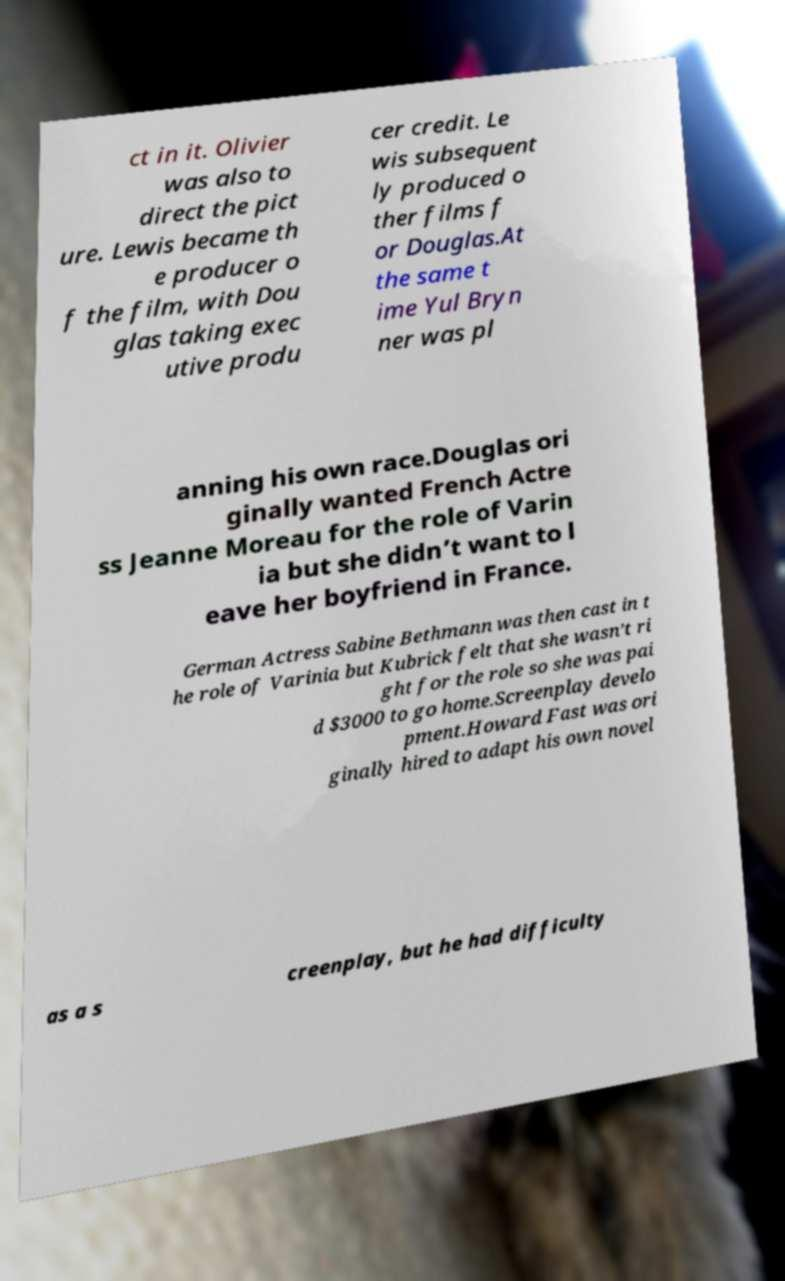What messages or text are displayed in this image? I need them in a readable, typed format. ct in it. Olivier was also to direct the pict ure. Lewis became th e producer o f the film, with Dou glas taking exec utive produ cer credit. Le wis subsequent ly produced o ther films f or Douglas.At the same t ime Yul Bryn ner was pl anning his own race.Douglas ori ginally wanted French Actre ss Jeanne Moreau for the role of Varin ia but she didn’t want to l eave her boyfriend in France. German Actress Sabine Bethmann was then cast in t he role of Varinia but Kubrick felt that she wasn’t ri ght for the role so she was pai d $3000 to go home.Screenplay develo pment.Howard Fast was ori ginally hired to adapt his own novel as a s creenplay, but he had difficulty 